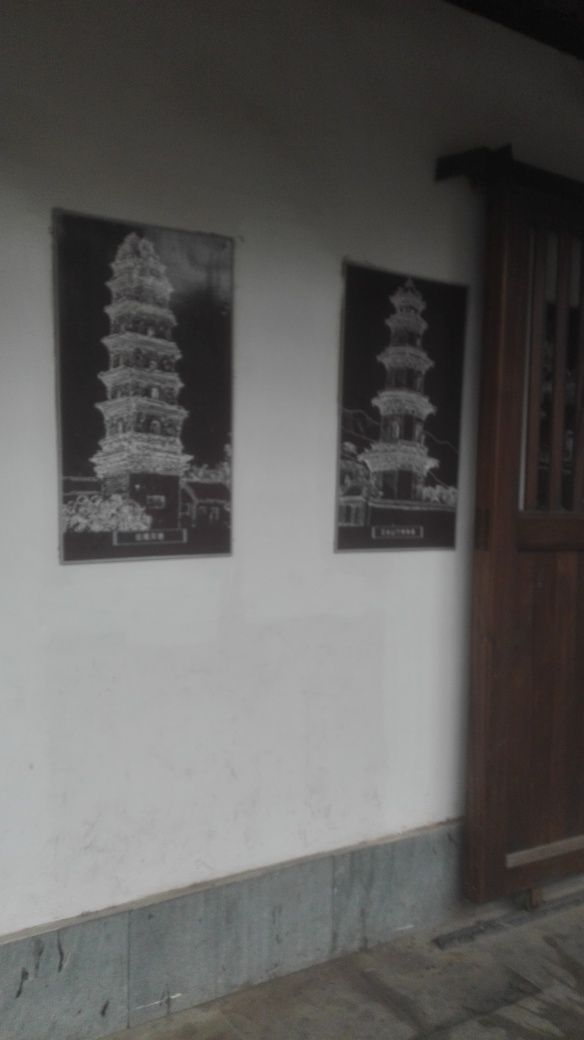What can you infer about the artistic style of the images within the frames? The artistic style of the images within the frames appears to be monochrome with high contrast, which emphasizes the architectural details of the pagodas. These works may be photographic prints or artistic renderings that focus on the structural beauty of these towers. 